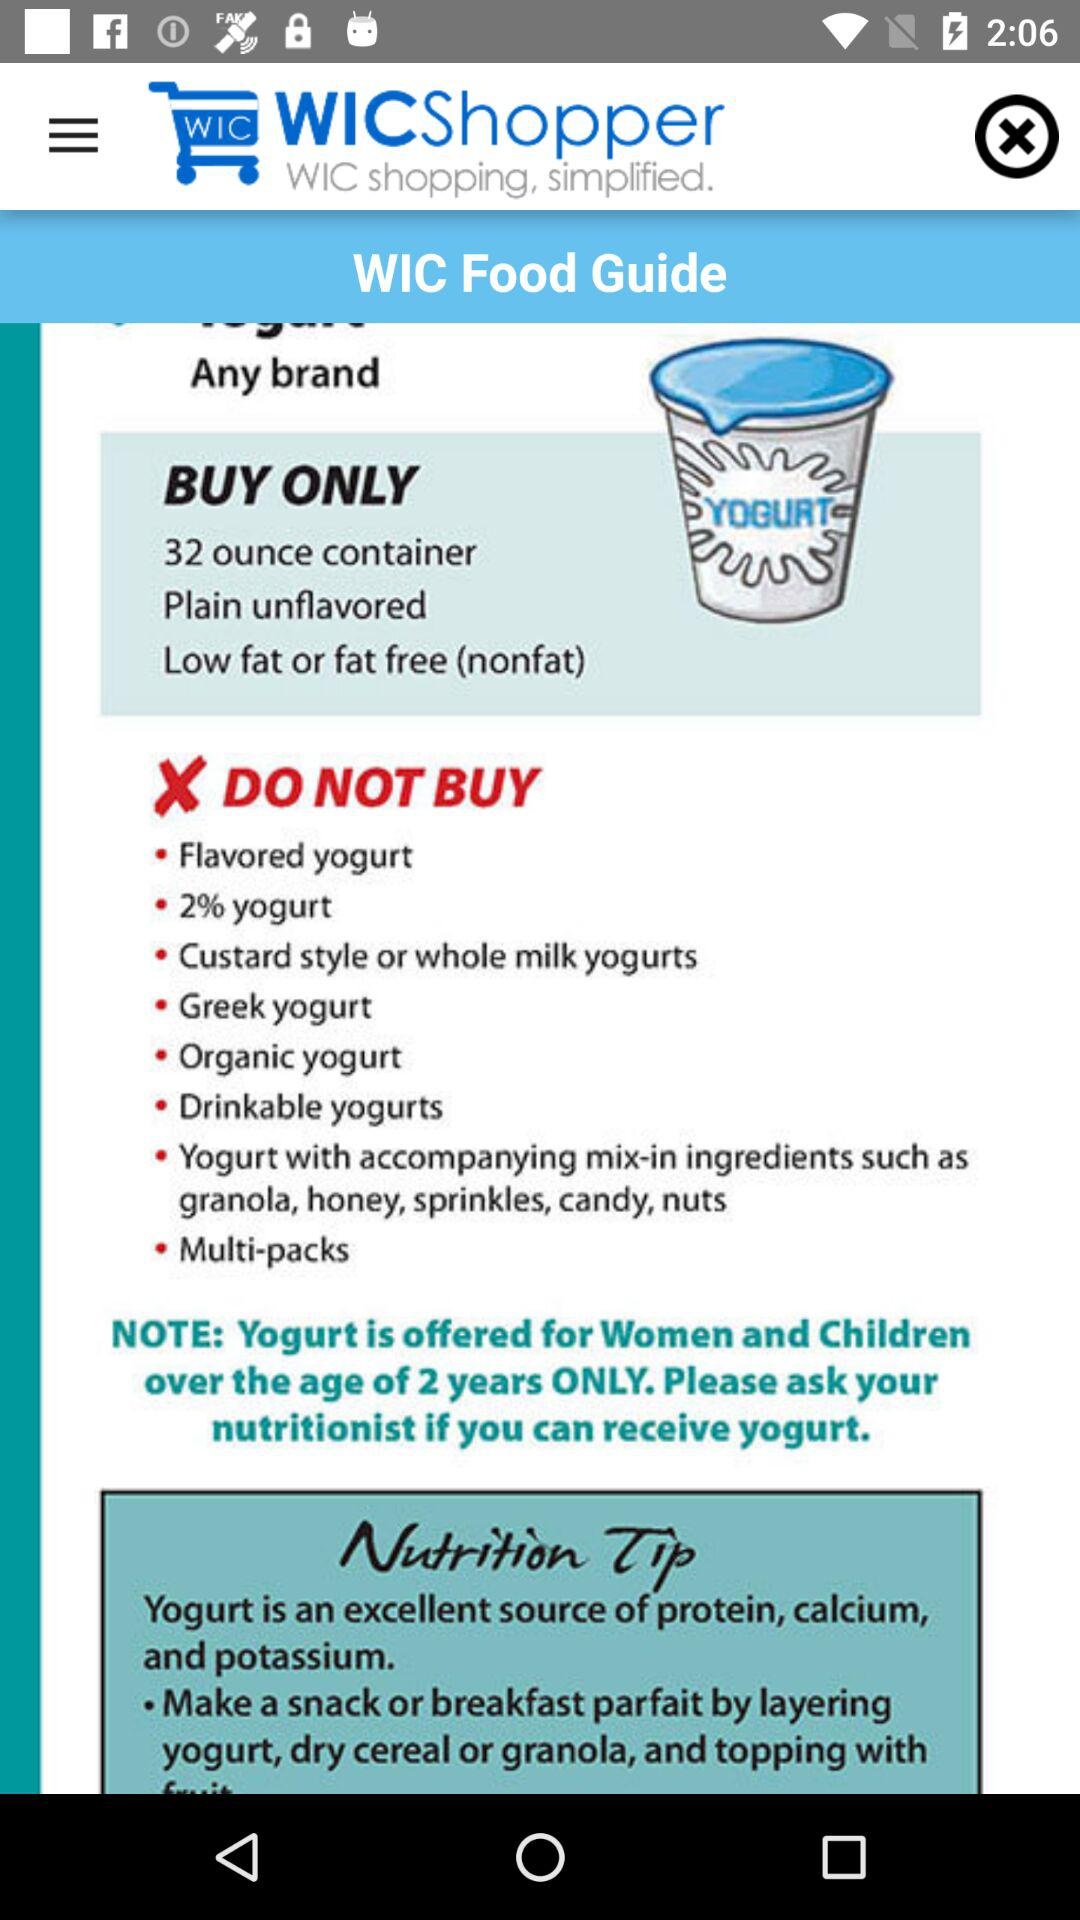What is the weight of the container? The weight of the container is 32 ounces. 